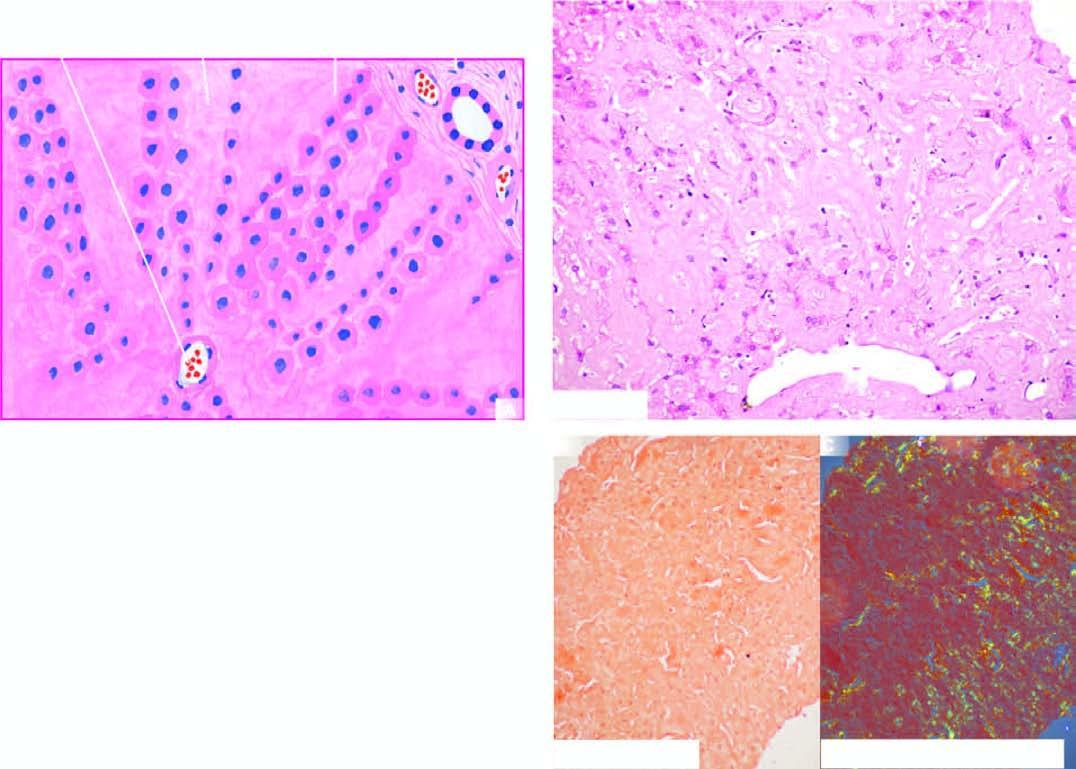what shows congophilia which under polarising microscopy?
Answer the question using a single word or phrase. Congo red staining 